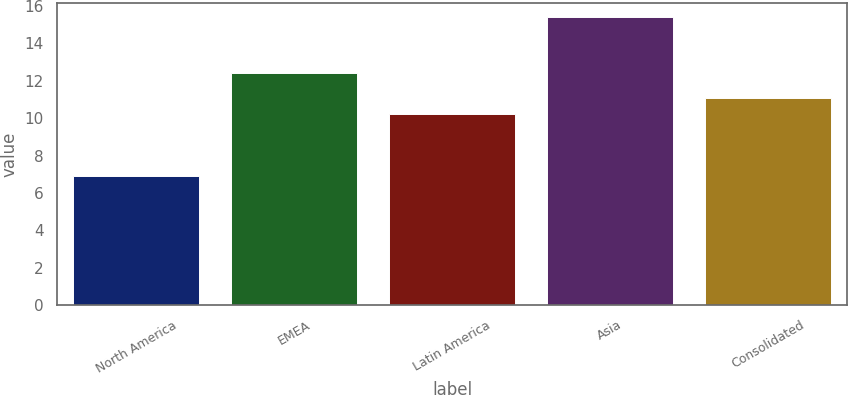Convert chart. <chart><loc_0><loc_0><loc_500><loc_500><bar_chart><fcel>North America<fcel>EMEA<fcel>Latin America<fcel>Asia<fcel>Consolidated<nl><fcel>6.9<fcel>12.4<fcel>10.2<fcel>15.4<fcel>11.05<nl></chart> 